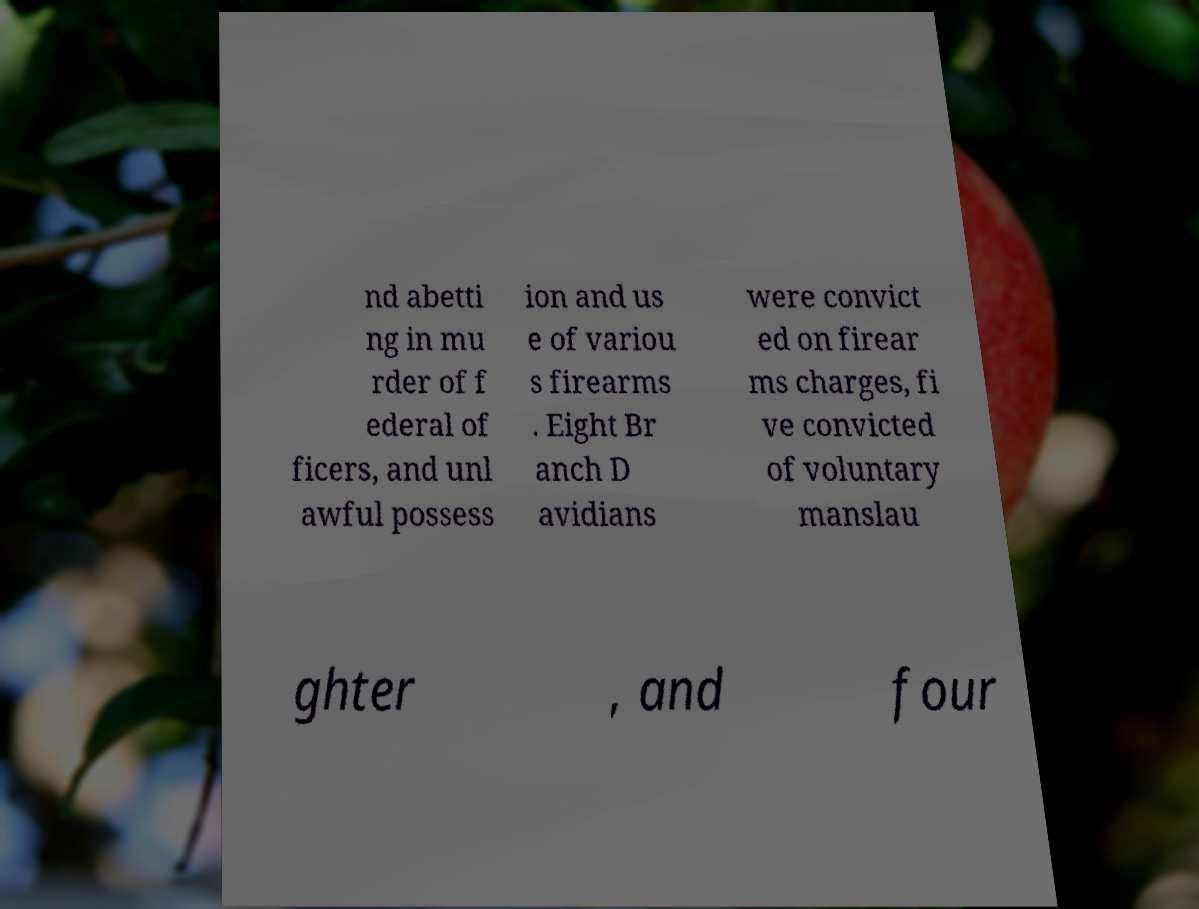I need the written content from this picture converted into text. Can you do that? nd abetti ng in mu rder of f ederal of ficers, and unl awful possess ion and us e of variou s firearms . Eight Br anch D avidians were convict ed on firear ms charges, fi ve convicted of voluntary manslau ghter , and four 